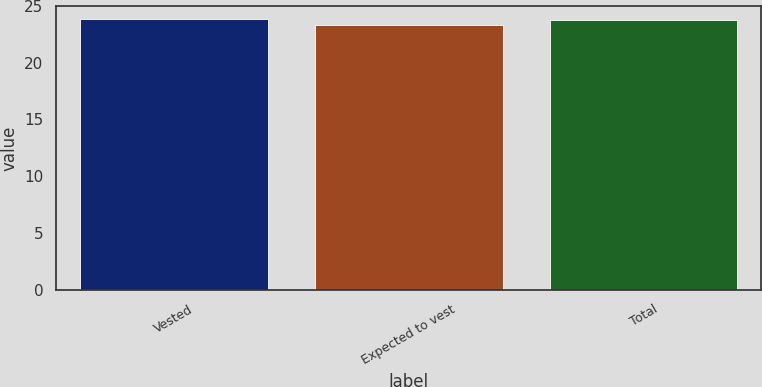<chart> <loc_0><loc_0><loc_500><loc_500><bar_chart><fcel>Vested<fcel>Expected to vest<fcel>Total<nl><fcel>23.81<fcel>23.33<fcel>23.74<nl></chart> 